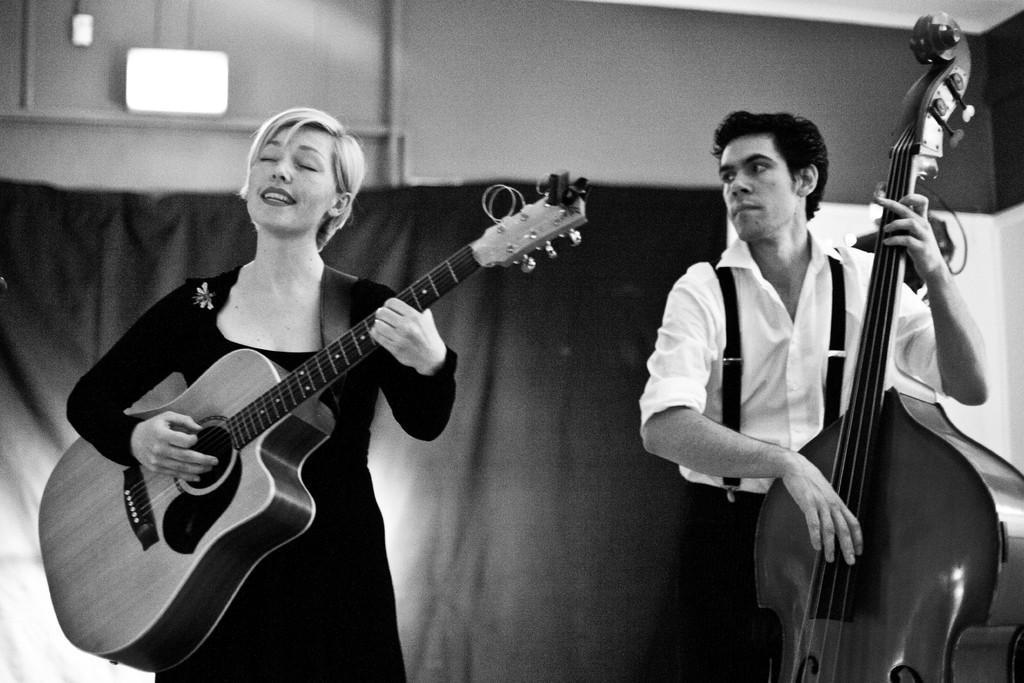Please provide a concise description of this image. This is a black and white picture. On the background there is a wall and a curtain. Here we can see a man and a woman standing and playing musical instruments. 